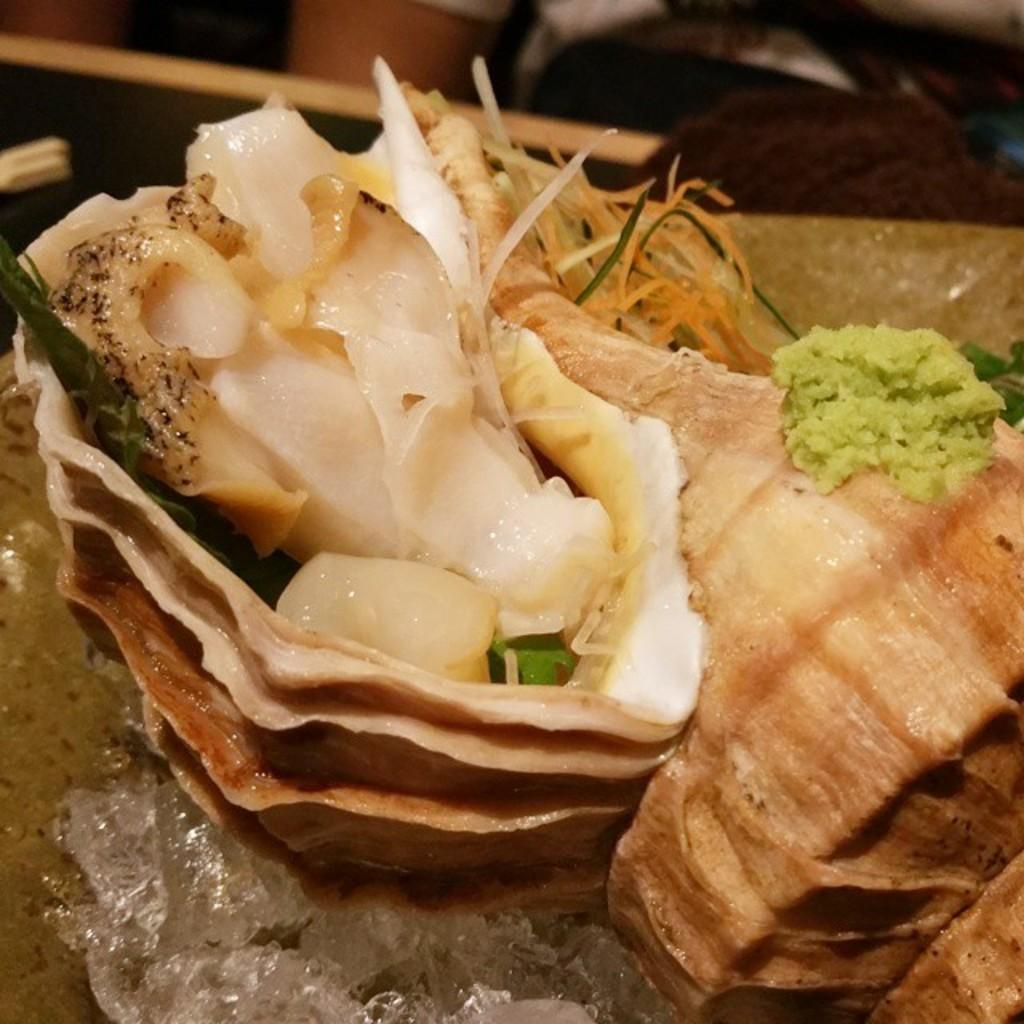What is the main subject in the foreground of the image? There is a food item and ice cubes in the foreground of the image. Can you describe the food item in the image? Unfortunately, the specific food item cannot be identified from the provided facts. What is the condition of the top part of the image? The top part of the image appears blurred. Are there any dinosaurs visible in the image? No, there are no dinosaurs present in the image. Is it raining in the image? There is no information about the weather or any rain in the image. 